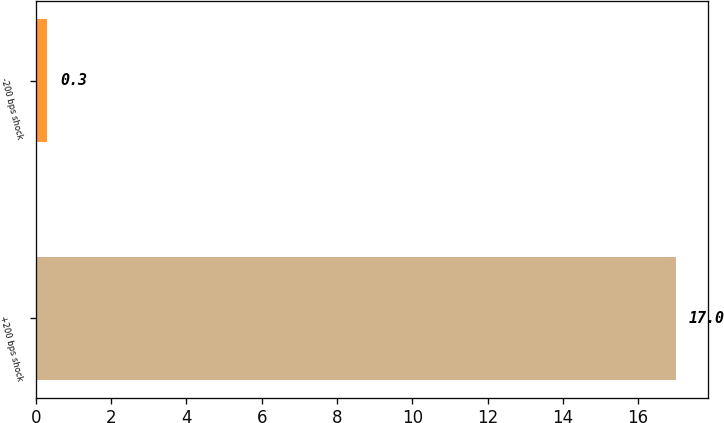<chart> <loc_0><loc_0><loc_500><loc_500><bar_chart><fcel>+200 bps shock<fcel>-200 bps shock<nl><fcel>17<fcel>0.3<nl></chart> 